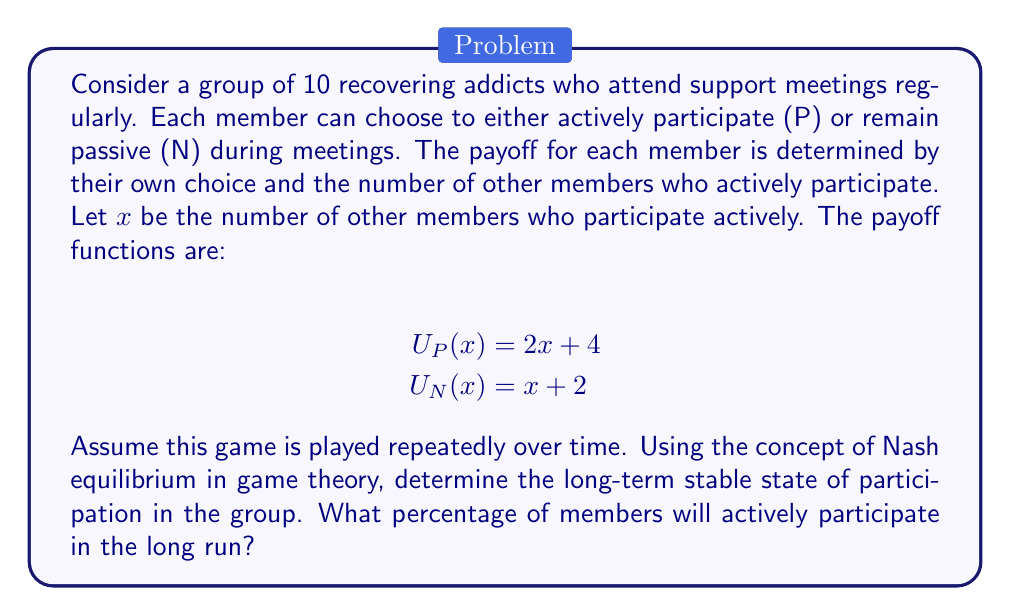Could you help me with this problem? To solve this problem, we'll follow these steps:

1) First, we need to find the Nash equilibrium of this game. In a Nash equilibrium, no player can unilaterally improve their payoff by changing their strategy.

2) For a member to be indifferent between participating (P) and not participating (N), the payoffs must be equal:

   $$U_P(x) = U_N(x)$$
   $$2x + 4 = x + 2$$
   $$x = 2$$

3) This means that when 2 other members are participating, a member is indifferent between P and N.

4) In a group of 10, if 3 members are participating (including the member we're considering), then 7 are not participating. This is a stable state because:
   - For participating members: $U_P(2) = 2(2) + 4 = 8$
   - For non-participating members: $U_N(3) = 3 + 2 = 5$

   Participating members have no incentive to stop, and non-participating members have no incentive to start participating.

5) Therefore, in the long-term stable state, 3 out of 10 members will actively participate.

6) To calculate the percentage:
   $$(3 / 10) * 100 = 30\%$$

Thus, 30% of members will actively participate in the long run.
Answer: 30% 